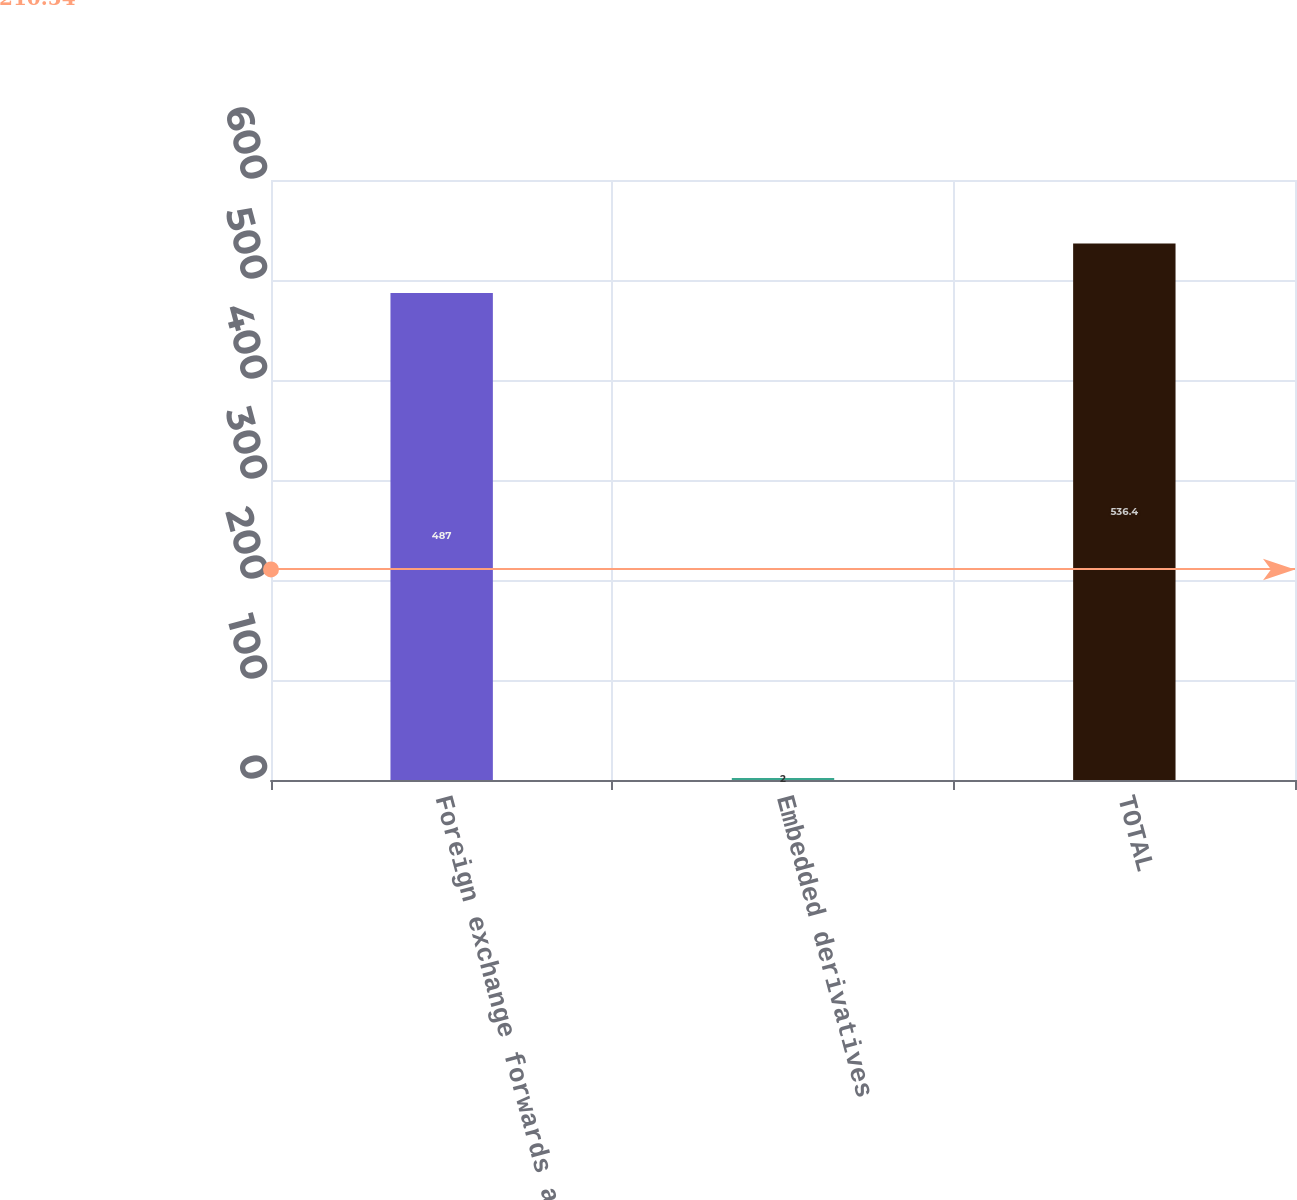Convert chart to OTSL. <chart><loc_0><loc_0><loc_500><loc_500><bar_chart><fcel>Foreign exchange forwards and<fcel>Embedded derivatives<fcel>TOTAL<nl><fcel>487<fcel>2<fcel>536.4<nl></chart> 